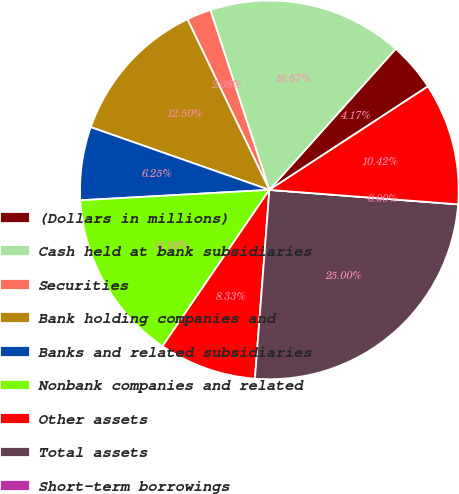<chart> <loc_0><loc_0><loc_500><loc_500><pie_chart><fcel>(Dollars in millions)<fcel>Cash held at bank subsidiaries<fcel>Securities<fcel>Bank holding companies and<fcel>Banks and related subsidiaries<fcel>Nonbank companies and related<fcel>Other assets<fcel>Total assets<fcel>Short-term borrowings<fcel>Accrued expenses and other<nl><fcel>4.17%<fcel>16.67%<fcel>2.08%<fcel>12.5%<fcel>6.25%<fcel>14.58%<fcel>8.33%<fcel>25.0%<fcel>0.0%<fcel>10.42%<nl></chart> 